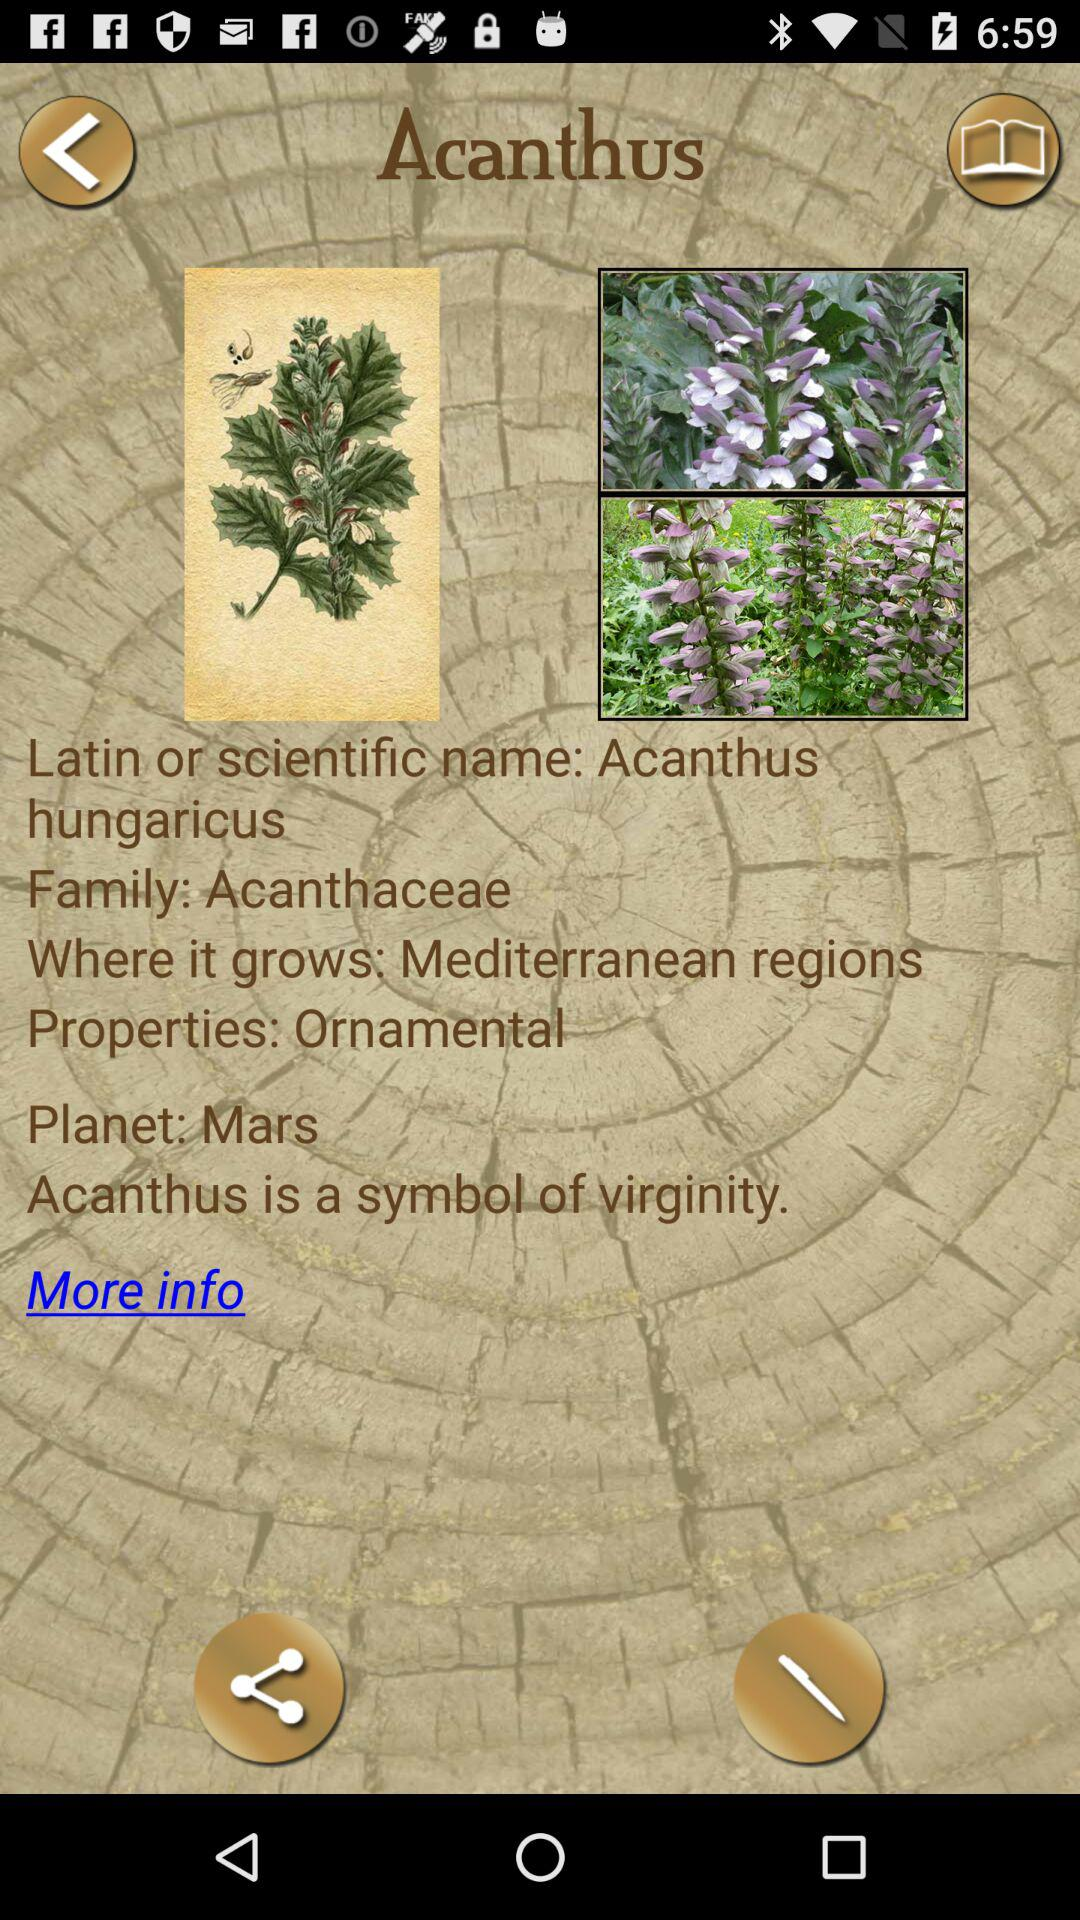What does Acanthus represents?
Answer the question using a single word or phrase. Acanthus represents "virginity". 